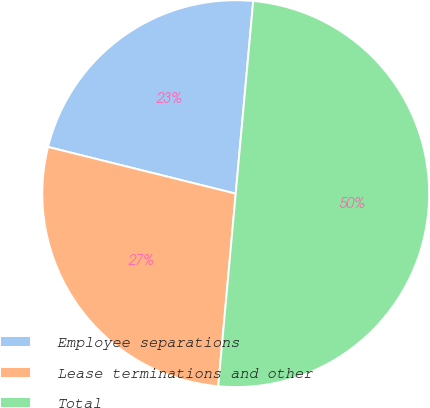Convert chart. <chart><loc_0><loc_0><loc_500><loc_500><pie_chart><fcel>Employee separations<fcel>Lease terminations and other<fcel>Total<nl><fcel>22.56%<fcel>27.44%<fcel>50.0%<nl></chart> 